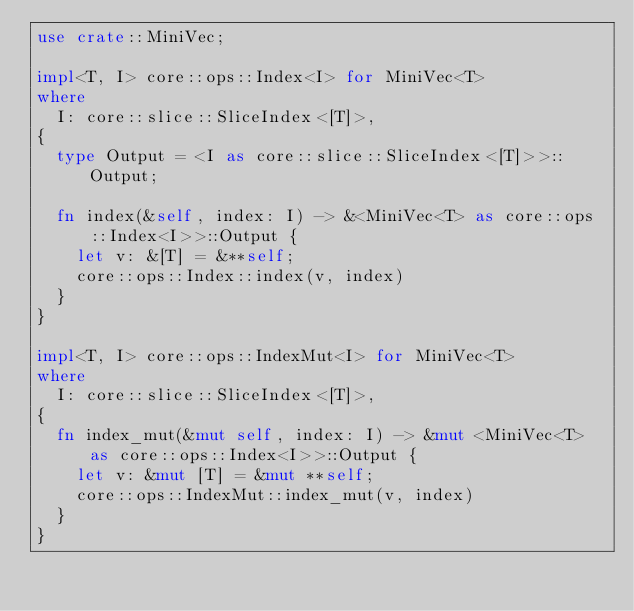<code> <loc_0><loc_0><loc_500><loc_500><_Rust_>use crate::MiniVec;

impl<T, I> core::ops::Index<I> for MiniVec<T>
where
  I: core::slice::SliceIndex<[T]>,
{
  type Output = <I as core::slice::SliceIndex<[T]>>::Output;

  fn index(&self, index: I) -> &<MiniVec<T> as core::ops::Index<I>>::Output {
    let v: &[T] = &**self;
    core::ops::Index::index(v, index)
  }
}

impl<T, I> core::ops::IndexMut<I> for MiniVec<T>
where
  I: core::slice::SliceIndex<[T]>,
{
  fn index_mut(&mut self, index: I) -> &mut <MiniVec<T> as core::ops::Index<I>>::Output {
    let v: &mut [T] = &mut **self;
    core::ops::IndexMut::index_mut(v, index)
  }
}
</code> 